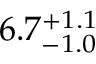<formula> <loc_0><loc_0><loc_500><loc_500>6 . 7 _ { - 1 . 0 } ^ { + 1 . 1 }</formula> 